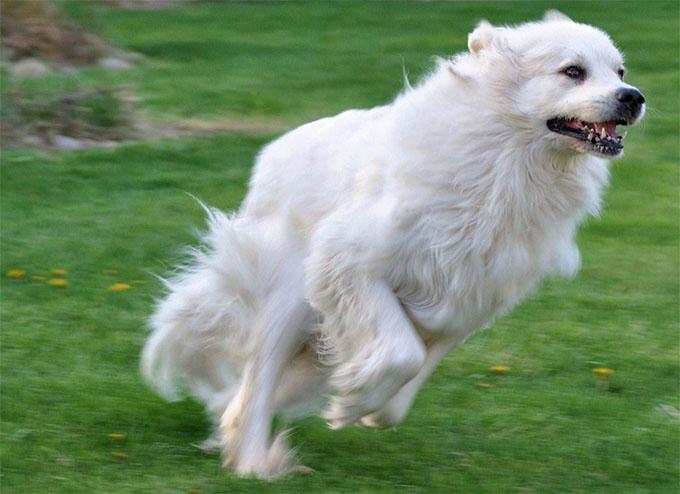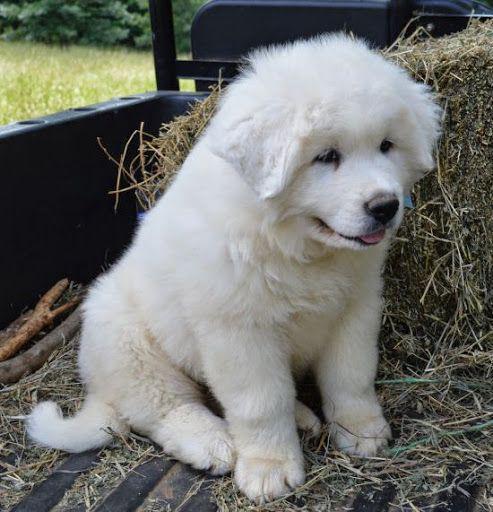The first image is the image on the left, the second image is the image on the right. For the images shown, is this caption "An image shows a white dog with a herd of livestock." true? Answer yes or no. No. The first image is the image on the left, the second image is the image on the right. Evaluate the accuracy of this statement regarding the images: "The white dog is lying in the grass in the image on the left.". Is it true? Answer yes or no. No. 